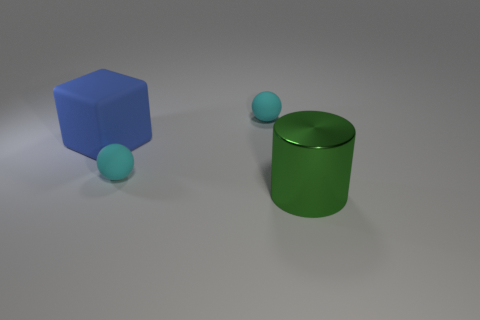What color is the large thing that is on the right side of the small cyan object behind the big rubber thing?
Your answer should be compact. Green. Is there a cyan sphere on the left side of the sphere behind the big thing behind the green shiny cylinder?
Provide a short and direct response. Yes. Is there any other thing of the same color as the rubber cube?
Provide a short and direct response. No. Do the small matte ball that is behind the large blue thing and the small thing that is in front of the big cube have the same color?
Give a very brief answer. Yes. Are there any large blue objects?
Your answer should be compact. Yes. Is there a small cyan ball that has the same material as the large blue object?
Your response must be concise. Yes. Is there any other thing that has the same material as the green object?
Offer a very short reply. No. What is the color of the big metallic cylinder?
Offer a terse response. Green. What is the color of the rubber block that is the same size as the green shiny object?
Provide a succinct answer. Blue. What number of shiny objects are big brown cylinders or small cyan objects?
Your answer should be very brief. 0. 